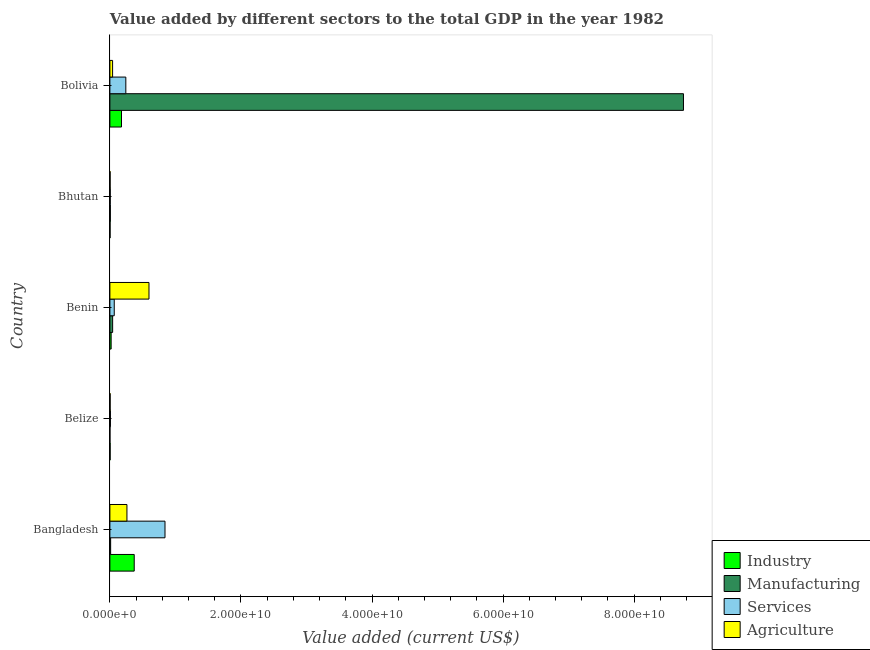How many different coloured bars are there?
Offer a very short reply. 4. Are the number of bars per tick equal to the number of legend labels?
Give a very brief answer. Yes. How many bars are there on the 4th tick from the top?
Offer a terse response. 4. How many bars are there on the 5th tick from the bottom?
Provide a succinct answer. 4. What is the label of the 5th group of bars from the top?
Give a very brief answer. Bangladesh. What is the value added by manufacturing sector in Benin?
Offer a terse response. 4.20e+08. Across all countries, what is the maximum value added by industrial sector?
Make the answer very short. 3.71e+09. Across all countries, what is the minimum value added by services sector?
Give a very brief answer. 5.63e+07. In which country was the value added by industrial sector minimum?
Your answer should be very brief. Bhutan. What is the total value added by industrial sector in the graph?
Make the answer very short. 5.74e+09. What is the difference between the value added by services sector in Benin and that in Bhutan?
Offer a very short reply. 6.08e+08. What is the difference between the value added by manufacturing sector in Bangladesh and the value added by agricultural sector in Belize?
Provide a short and direct response. 7.68e+07. What is the average value added by industrial sector per country?
Ensure brevity in your answer.  1.15e+09. What is the difference between the value added by industrial sector and value added by agricultural sector in Bangladesh?
Offer a very short reply. 1.11e+09. What is the ratio of the value added by services sector in Bhutan to that in Bolivia?
Offer a very short reply. 0.02. Is the value added by manufacturing sector in Bangladesh less than that in Belize?
Give a very brief answer. No. Is the difference between the value added by services sector in Belize and Bhutan greater than the difference between the value added by agricultural sector in Belize and Bhutan?
Your response must be concise. Yes. What is the difference between the highest and the second highest value added by agricultural sector?
Your answer should be compact. 3.36e+09. What is the difference between the highest and the lowest value added by agricultural sector?
Your response must be concise. 5.93e+09. In how many countries, is the value added by manufacturing sector greater than the average value added by manufacturing sector taken over all countries?
Keep it short and to the point. 1. Is the sum of the value added by services sector in Belize and Bhutan greater than the maximum value added by agricultural sector across all countries?
Your response must be concise. No. Is it the case that in every country, the sum of the value added by manufacturing sector and value added by agricultural sector is greater than the sum of value added by industrial sector and value added by services sector?
Keep it short and to the point. No. What does the 2nd bar from the top in Bangladesh represents?
Provide a succinct answer. Services. What does the 3rd bar from the bottom in Bangladesh represents?
Provide a short and direct response. Services. Is it the case that in every country, the sum of the value added by industrial sector and value added by manufacturing sector is greater than the value added by services sector?
Make the answer very short. No. How many bars are there?
Your answer should be compact. 20. What is the difference between two consecutive major ticks on the X-axis?
Your response must be concise. 2.00e+1. Are the values on the major ticks of X-axis written in scientific E-notation?
Ensure brevity in your answer.  Yes. Does the graph contain grids?
Provide a short and direct response. No. How many legend labels are there?
Your response must be concise. 4. How are the legend labels stacked?
Provide a short and direct response. Vertical. What is the title of the graph?
Ensure brevity in your answer.  Value added by different sectors to the total GDP in the year 1982. Does "UNPBF" appear as one of the legend labels in the graph?
Ensure brevity in your answer.  No. What is the label or title of the X-axis?
Provide a succinct answer. Value added (current US$). What is the Value added (current US$) in Industry in Bangladesh?
Offer a terse response. 3.71e+09. What is the Value added (current US$) in Manufacturing in Bangladesh?
Offer a very short reply. 1.15e+08. What is the Value added (current US$) in Services in Bangladesh?
Offer a very short reply. 8.41e+09. What is the Value added (current US$) of Agriculture in Bangladesh?
Your answer should be compact. 2.60e+09. What is the Value added (current US$) in Industry in Belize?
Offer a very short reply. 3.82e+07. What is the Value added (current US$) of Manufacturing in Belize?
Offer a terse response. 8.23e+06. What is the Value added (current US$) in Services in Belize?
Make the answer very short. 8.36e+07. What is the Value added (current US$) in Agriculture in Belize?
Your response must be concise. 3.86e+07. What is the Value added (current US$) of Industry in Benin?
Provide a succinct answer. 1.92e+08. What is the Value added (current US$) in Manufacturing in Benin?
Keep it short and to the point. 4.20e+08. What is the Value added (current US$) of Services in Benin?
Offer a very short reply. 6.64e+08. What is the Value added (current US$) in Agriculture in Benin?
Your answer should be compact. 5.96e+09. What is the Value added (current US$) of Industry in Bhutan?
Offer a terse response. 2.83e+07. What is the Value added (current US$) of Manufacturing in Bhutan?
Keep it short and to the point. 6.89e+07. What is the Value added (current US$) of Services in Bhutan?
Your answer should be very brief. 5.63e+07. What is the Value added (current US$) of Agriculture in Bhutan?
Provide a succinct answer. 3.54e+07. What is the Value added (current US$) of Industry in Bolivia?
Give a very brief answer. 1.77e+09. What is the Value added (current US$) in Manufacturing in Bolivia?
Provide a short and direct response. 8.75e+1. What is the Value added (current US$) in Services in Bolivia?
Ensure brevity in your answer.  2.43e+09. What is the Value added (current US$) in Agriculture in Bolivia?
Make the answer very short. 4.12e+08. Across all countries, what is the maximum Value added (current US$) in Industry?
Give a very brief answer. 3.71e+09. Across all countries, what is the maximum Value added (current US$) in Manufacturing?
Give a very brief answer. 8.75e+1. Across all countries, what is the maximum Value added (current US$) of Services?
Make the answer very short. 8.41e+09. Across all countries, what is the maximum Value added (current US$) in Agriculture?
Provide a succinct answer. 5.96e+09. Across all countries, what is the minimum Value added (current US$) of Industry?
Give a very brief answer. 2.83e+07. Across all countries, what is the minimum Value added (current US$) of Manufacturing?
Make the answer very short. 8.23e+06. Across all countries, what is the minimum Value added (current US$) of Services?
Your answer should be very brief. 5.63e+07. Across all countries, what is the minimum Value added (current US$) of Agriculture?
Provide a short and direct response. 3.54e+07. What is the total Value added (current US$) in Industry in the graph?
Ensure brevity in your answer.  5.74e+09. What is the total Value added (current US$) of Manufacturing in the graph?
Provide a short and direct response. 8.81e+1. What is the total Value added (current US$) in Services in the graph?
Your answer should be very brief. 1.16e+1. What is the total Value added (current US$) of Agriculture in the graph?
Your response must be concise. 9.05e+09. What is the difference between the Value added (current US$) of Industry in Bangladesh and that in Belize?
Ensure brevity in your answer.  3.67e+09. What is the difference between the Value added (current US$) of Manufacturing in Bangladesh and that in Belize?
Offer a terse response. 1.07e+08. What is the difference between the Value added (current US$) of Services in Bangladesh and that in Belize?
Ensure brevity in your answer.  8.32e+09. What is the difference between the Value added (current US$) in Agriculture in Bangladesh and that in Belize?
Provide a succinct answer. 2.56e+09. What is the difference between the Value added (current US$) in Industry in Bangladesh and that in Benin?
Provide a short and direct response. 3.52e+09. What is the difference between the Value added (current US$) of Manufacturing in Bangladesh and that in Benin?
Provide a short and direct response. -3.04e+08. What is the difference between the Value added (current US$) of Services in Bangladesh and that in Benin?
Give a very brief answer. 7.74e+09. What is the difference between the Value added (current US$) in Agriculture in Bangladesh and that in Benin?
Give a very brief answer. -3.36e+09. What is the difference between the Value added (current US$) of Industry in Bangladesh and that in Bhutan?
Your response must be concise. 3.68e+09. What is the difference between the Value added (current US$) in Manufacturing in Bangladesh and that in Bhutan?
Your answer should be compact. 4.64e+07. What is the difference between the Value added (current US$) in Services in Bangladesh and that in Bhutan?
Ensure brevity in your answer.  8.35e+09. What is the difference between the Value added (current US$) in Agriculture in Bangladesh and that in Bhutan?
Give a very brief answer. 2.56e+09. What is the difference between the Value added (current US$) in Industry in Bangladesh and that in Bolivia?
Your response must be concise. 1.94e+09. What is the difference between the Value added (current US$) of Manufacturing in Bangladesh and that in Bolivia?
Make the answer very short. -8.74e+1. What is the difference between the Value added (current US$) of Services in Bangladesh and that in Bolivia?
Your response must be concise. 5.98e+09. What is the difference between the Value added (current US$) of Agriculture in Bangladesh and that in Bolivia?
Your response must be concise. 2.19e+09. What is the difference between the Value added (current US$) of Industry in Belize and that in Benin?
Provide a short and direct response. -1.54e+08. What is the difference between the Value added (current US$) of Manufacturing in Belize and that in Benin?
Your answer should be compact. -4.12e+08. What is the difference between the Value added (current US$) of Services in Belize and that in Benin?
Keep it short and to the point. -5.80e+08. What is the difference between the Value added (current US$) of Agriculture in Belize and that in Benin?
Provide a succinct answer. -5.93e+09. What is the difference between the Value added (current US$) in Industry in Belize and that in Bhutan?
Keep it short and to the point. 9.86e+06. What is the difference between the Value added (current US$) of Manufacturing in Belize and that in Bhutan?
Give a very brief answer. -6.07e+07. What is the difference between the Value added (current US$) of Services in Belize and that in Bhutan?
Make the answer very short. 2.73e+07. What is the difference between the Value added (current US$) in Agriculture in Belize and that in Bhutan?
Your answer should be very brief. 3.16e+06. What is the difference between the Value added (current US$) in Industry in Belize and that in Bolivia?
Your answer should be very brief. -1.73e+09. What is the difference between the Value added (current US$) in Manufacturing in Belize and that in Bolivia?
Provide a succinct answer. -8.75e+1. What is the difference between the Value added (current US$) in Services in Belize and that in Bolivia?
Provide a short and direct response. -2.35e+09. What is the difference between the Value added (current US$) of Agriculture in Belize and that in Bolivia?
Make the answer very short. -3.73e+08. What is the difference between the Value added (current US$) of Industry in Benin and that in Bhutan?
Offer a very short reply. 1.63e+08. What is the difference between the Value added (current US$) in Manufacturing in Benin and that in Bhutan?
Keep it short and to the point. 3.51e+08. What is the difference between the Value added (current US$) in Services in Benin and that in Bhutan?
Offer a very short reply. 6.08e+08. What is the difference between the Value added (current US$) of Agriculture in Benin and that in Bhutan?
Make the answer very short. 5.93e+09. What is the difference between the Value added (current US$) in Industry in Benin and that in Bolivia?
Ensure brevity in your answer.  -1.58e+09. What is the difference between the Value added (current US$) of Manufacturing in Benin and that in Bolivia?
Offer a very short reply. -8.71e+1. What is the difference between the Value added (current US$) of Services in Benin and that in Bolivia?
Provide a short and direct response. -1.77e+09. What is the difference between the Value added (current US$) in Agriculture in Benin and that in Bolivia?
Provide a succinct answer. 5.55e+09. What is the difference between the Value added (current US$) of Industry in Bhutan and that in Bolivia?
Keep it short and to the point. -1.74e+09. What is the difference between the Value added (current US$) of Manufacturing in Bhutan and that in Bolivia?
Provide a succinct answer. -8.75e+1. What is the difference between the Value added (current US$) in Services in Bhutan and that in Bolivia?
Offer a very short reply. -2.38e+09. What is the difference between the Value added (current US$) of Agriculture in Bhutan and that in Bolivia?
Give a very brief answer. -3.77e+08. What is the difference between the Value added (current US$) of Industry in Bangladesh and the Value added (current US$) of Manufacturing in Belize?
Make the answer very short. 3.70e+09. What is the difference between the Value added (current US$) in Industry in Bangladesh and the Value added (current US$) in Services in Belize?
Keep it short and to the point. 3.63e+09. What is the difference between the Value added (current US$) in Industry in Bangladesh and the Value added (current US$) in Agriculture in Belize?
Offer a very short reply. 3.67e+09. What is the difference between the Value added (current US$) in Manufacturing in Bangladesh and the Value added (current US$) in Services in Belize?
Your answer should be compact. 3.17e+07. What is the difference between the Value added (current US$) of Manufacturing in Bangladesh and the Value added (current US$) of Agriculture in Belize?
Ensure brevity in your answer.  7.68e+07. What is the difference between the Value added (current US$) in Services in Bangladesh and the Value added (current US$) in Agriculture in Belize?
Your answer should be compact. 8.37e+09. What is the difference between the Value added (current US$) in Industry in Bangladesh and the Value added (current US$) in Manufacturing in Benin?
Ensure brevity in your answer.  3.29e+09. What is the difference between the Value added (current US$) of Industry in Bangladesh and the Value added (current US$) of Services in Benin?
Your answer should be very brief. 3.05e+09. What is the difference between the Value added (current US$) in Industry in Bangladesh and the Value added (current US$) in Agriculture in Benin?
Provide a short and direct response. -2.25e+09. What is the difference between the Value added (current US$) in Manufacturing in Bangladesh and the Value added (current US$) in Services in Benin?
Give a very brief answer. -5.49e+08. What is the difference between the Value added (current US$) of Manufacturing in Bangladesh and the Value added (current US$) of Agriculture in Benin?
Give a very brief answer. -5.85e+09. What is the difference between the Value added (current US$) of Services in Bangladesh and the Value added (current US$) of Agriculture in Benin?
Make the answer very short. 2.44e+09. What is the difference between the Value added (current US$) in Industry in Bangladesh and the Value added (current US$) in Manufacturing in Bhutan?
Your answer should be very brief. 3.64e+09. What is the difference between the Value added (current US$) in Industry in Bangladesh and the Value added (current US$) in Services in Bhutan?
Give a very brief answer. 3.66e+09. What is the difference between the Value added (current US$) in Industry in Bangladesh and the Value added (current US$) in Agriculture in Bhutan?
Make the answer very short. 3.68e+09. What is the difference between the Value added (current US$) of Manufacturing in Bangladesh and the Value added (current US$) of Services in Bhutan?
Your answer should be very brief. 5.90e+07. What is the difference between the Value added (current US$) of Manufacturing in Bangladesh and the Value added (current US$) of Agriculture in Bhutan?
Ensure brevity in your answer.  7.99e+07. What is the difference between the Value added (current US$) of Services in Bangladesh and the Value added (current US$) of Agriculture in Bhutan?
Your answer should be compact. 8.37e+09. What is the difference between the Value added (current US$) of Industry in Bangladesh and the Value added (current US$) of Manufacturing in Bolivia?
Provide a succinct answer. -8.38e+1. What is the difference between the Value added (current US$) in Industry in Bangladesh and the Value added (current US$) in Services in Bolivia?
Give a very brief answer. 1.28e+09. What is the difference between the Value added (current US$) in Industry in Bangladesh and the Value added (current US$) in Agriculture in Bolivia?
Give a very brief answer. 3.30e+09. What is the difference between the Value added (current US$) of Manufacturing in Bangladesh and the Value added (current US$) of Services in Bolivia?
Your answer should be compact. -2.32e+09. What is the difference between the Value added (current US$) in Manufacturing in Bangladesh and the Value added (current US$) in Agriculture in Bolivia?
Your answer should be compact. -2.97e+08. What is the difference between the Value added (current US$) in Services in Bangladesh and the Value added (current US$) in Agriculture in Bolivia?
Keep it short and to the point. 8.00e+09. What is the difference between the Value added (current US$) of Industry in Belize and the Value added (current US$) of Manufacturing in Benin?
Offer a terse response. -3.82e+08. What is the difference between the Value added (current US$) in Industry in Belize and the Value added (current US$) in Services in Benin?
Offer a very short reply. -6.26e+08. What is the difference between the Value added (current US$) of Industry in Belize and the Value added (current US$) of Agriculture in Benin?
Give a very brief answer. -5.93e+09. What is the difference between the Value added (current US$) of Manufacturing in Belize and the Value added (current US$) of Services in Benin?
Offer a very short reply. -6.56e+08. What is the difference between the Value added (current US$) of Manufacturing in Belize and the Value added (current US$) of Agriculture in Benin?
Your answer should be very brief. -5.96e+09. What is the difference between the Value added (current US$) of Services in Belize and the Value added (current US$) of Agriculture in Benin?
Your response must be concise. -5.88e+09. What is the difference between the Value added (current US$) of Industry in Belize and the Value added (current US$) of Manufacturing in Bhutan?
Your response must be concise. -3.07e+07. What is the difference between the Value added (current US$) in Industry in Belize and the Value added (current US$) in Services in Bhutan?
Your response must be concise. -1.81e+07. What is the difference between the Value added (current US$) of Industry in Belize and the Value added (current US$) of Agriculture in Bhutan?
Give a very brief answer. 2.80e+06. What is the difference between the Value added (current US$) of Manufacturing in Belize and the Value added (current US$) of Services in Bhutan?
Provide a succinct answer. -4.81e+07. What is the difference between the Value added (current US$) in Manufacturing in Belize and the Value added (current US$) in Agriculture in Bhutan?
Offer a very short reply. -2.72e+07. What is the difference between the Value added (current US$) of Services in Belize and the Value added (current US$) of Agriculture in Bhutan?
Your answer should be very brief. 4.82e+07. What is the difference between the Value added (current US$) in Industry in Belize and the Value added (current US$) in Manufacturing in Bolivia?
Offer a terse response. -8.75e+1. What is the difference between the Value added (current US$) in Industry in Belize and the Value added (current US$) in Services in Bolivia?
Provide a short and direct response. -2.39e+09. What is the difference between the Value added (current US$) of Industry in Belize and the Value added (current US$) of Agriculture in Bolivia?
Provide a succinct answer. -3.74e+08. What is the difference between the Value added (current US$) in Manufacturing in Belize and the Value added (current US$) in Services in Bolivia?
Provide a short and direct response. -2.42e+09. What is the difference between the Value added (current US$) of Manufacturing in Belize and the Value added (current US$) of Agriculture in Bolivia?
Offer a very short reply. -4.04e+08. What is the difference between the Value added (current US$) in Services in Belize and the Value added (current US$) in Agriculture in Bolivia?
Ensure brevity in your answer.  -3.28e+08. What is the difference between the Value added (current US$) of Industry in Benin and the Value added (current US$) of Manufacturing in Bhutan?
Keep it short and to the point. 1.23e+08. What is the difference between the Value added (current US$) of Industry in Benin and the Value added (current US$) of Services in Bhutan?
Keep it short and to the point. 1.35e+08. What is the difference between the Value added (current US$) in Industry in Benin and the Value added (current US$) in Agriculture in Bhutan?
Keep it short and to the point. 1.56e+08. What is the difference between the Value added (current US$) of Manufacturing in Benin and the Value added (current US$) of Services in Bhutan?
Offer a terse response. 3.63e+08. What is the difference between the Value added (current US$) of Manufacturing in Benin and the Value added (current US$) of Agriculture in Bhutan?
Your answer should be very brief. 3.84e+08. What is the difference between the Value added (current US$) in Services in Benin and the Value added (current US$) in Agriculture in Bhutan?
Make the answer very short. 6.29e+08. What is the difference between the Value added (current US$) of Industry in Benin and the Value added (current US$) of Manufacturing in Bolivia?
Keep it short and to the point. -8.73e+1. What is the difference between the Value added (current US$) in Industry in Benin and the Value added (current US$) in Services in Bolivia?
Make the answer very short. -2.24e+09. What is the difference between the Value added (current US$) of Industry in Benin and the Value added (current US$) of Agriculture in Bolivia?
Your response must be concise. -2.20e+08. What is the difference between the Value added (current US$) in Manufacturing in Benin and the Value added (current US$) in Services in Bolivia?
Your response must be concise. -2.01e+09. What is the difference between the Value added (current US$) of Manufacturing in Benin and the Value added (current US$) of Agriculture in Bolivia?
Make the answer very short. 7.73e+06. What is the difference between the Value added (current US$) in Services in Benin and the Value added (current US$) in Agriculture in Bolivia?
Your response must be concise. 2.52e+08. What is the difference between the Value added (current US$) in Industry in Bhutan and the Value added (current US$) in Manufacturing in Bolivia?
Your answer should be very brief. -8.75e+1. What is the difference between the Value added (current US$) of Industry in Bhutan and the Value added (current US$) of Services in Bolivia?
Provide a succinct answer. -2.40e+09. What is the difference between the Value added (current US$) of Industry in Bhutan and the Value added (current US$) of Agriculture in Bolivia?
Provide a succinct answer. -3.84e+08. What is the difference between the Value added (current US$) in Manufacturing in Bhutan and the Value added (current US$) in Services in Bolivia?
Your response must be concise. -2.36e+09. What is the difference between the Value added (current US$) of Manufacturing in Bhutan and the Value added (current US$) of Agriculture in Bolivia?
Your response must be concise. -3.43e+08. What is the difference between the Value added (current US$) of Services in Bhutan and the Value added (current US$) of Agriculture in Bolivia?
Make the answer very short. -3.56e+08. What is the average Value added (current US$) in Industry per country?
Your answer should be compact. 1.15e+09. What is the average Value added (current US$) in Manufacturing per country?
Provide a succinct answer. 1.76e+1. What is the average Value added (current US$) in Services per country?
Make the answer very short. 2.33e+09. What is the average Value added (current US$) in Agriculture per country?
Your answer should be very brief. 1.81e+09. What is the difference between the Value added (current US$) of Industry and Value added (current US$) of Manufacturing in Bangladesh?
Offer a terse response. 3.60e+09. What is the difference between the Value added (current US$) in Industry and Value added (current US$) in Services in Bangladesh?
Offer a terse response. -4.70e+09. What is the difference between the Value added (current US$) in Industry and Value added (current US$) in Agriculture in Bangladesh?
Keep it short and to the point. 1.11e+09. What is the difference between the Value added (current US$) of Manufacturing and Value added (current US$) of Services in Bangladesh?
Your response must be concise. -8.29e+09. What is the difference between the Value added (current US$) in Manufacturing and Value added (current US$) in Agriculture in Bangladesh?
Your answer should be very brief. -2.48e+09. What is the difference between the Value added (current US$) in Services and Value added (current US$) in Agriculture in Bangladesh?
Offer a very short reply. 5.81e+09. What is the difference between the Value added (current US$) of Industry and Value added (current US$) of Manufacturing in Belize?
Give a very brief answer. 3.00e+07. What is the difference between the Value added (current US$) in Industry and Value added (current US$) in Services in Belize?
Your answer should be compact. -4.54e+07. What is the difference between the Value added (current US$) of Industry and Value added (current US$) of Agriculture in Belize?
Ensure brevity in your answer.  -3.64e+05. What is the difference between the Value added (current US$) in Manufacturing and Value added (current US$) in Services in Belize?
Give a very brief answer. -7.54e+07. What is the difference between the Value added (current US$) of Manufacturing and Value added (current US$) of Agriculture in Belize?
Give a very brief answer. -3.03e+07. What is the difference between the Value added (current US$) in Services and Value added (current US$) in Agriculture in Belize?
Give a very brief answer. 4.51e+07. What is the difference between the Value added (current US$) in Industry and Value added (current US$) in Manufacturing in Benin?
Provide a succinct answer. -2.28e+08. What is the difference between the Value added (current US$) of Industry and Value added (current US$) of Services in Benin?
Make the answer very short. -4.72e+08. What is the difference between the Value added (current US$) in Industry and Value added (current US$) in Agriculture in Benin?
Make the answer very short. -5.77e+09. What is the difference between the Value added (current US$) of Manufacturing and Value added (current US$) of Services in Benin?
Keep it short and to the point. -2.44e+08. What is the difference between the Value added (current US$) in Manufacturing and Value added (current US$) in Agriculture in Benin?
Offer a terse response. -5.55e+09. What is the difference between the Value added (current US$) of Services and Value added (current US$) of Agriculture in Benin?
Provide a succinct answer. -5.30e+09. What is the difference between the Value added (current US$) in Industry and Value added (current US$) in Manufacturing in Bhutan?
Your response must be concise. -4.06e+07. What is the difference between the Value added (current US$) in Industry and Value added (current US$) in Services in Bhutan?
Offer a terse response. -2.80e+07. What is the difference between the Value added (current US$) in Industry and Value added (current US$) in Agriculture in Bhutan?
Provide a succinct answer. -7.06e+06. What is the difference between the Value added (current US$) in Manufacturing and Value added (current US$) in Services in Bhutan?
Your answer should be very brief. 1.26e+07. What is the difference between the Value added (current US$) of Manufacturing and Value added (current US$) of Agriculture in Bhutan?
Your answer should be compact. 3.35e+07. What is the difference between the Value added (current US$) of Services and Value added (current US$) of Agriculture in Bhutan?
Make the answer very short. 2.09e+07. What is the difference between the Value added (current US$) in Industry and Value added (current US$) in Manufacturing in Bolivia?
Offer a terse response. -8.58e+1. What is the difference between the Value added (current US$) of Industry and Value added (current US$) of Services in Bolivia?
Ensure brevity in your answer.  -6.60e+08. What is the difference between the Value added (current US$) of Industry and Value added (current US$) of Agriculture in Bolivia?
Your answer should be compact. 1.36e+09. What is the difference between the Value added (current US$) in Manufacturing and Value added (current US$) in Services in Bolivia?
Give a very brief answer. 8.51e+1. What is the difference between the Value added (current US$) in Manufacturing and Value added (current US$) in Agriculture in Bolivia?
Your response must be concise. 8.71e+1. What is the difference between the Value added (current US$) of Services and Value added (current US$) of Agriculture in Bolivia?
Ensure brevity in your answer.  2.02e+09. What is the ratio of the Value added (current US$) in Industry in Bangladesh to that in Belize?
Make the answer very short. 97.2. What is the ratio of the Value added (current US$) of Manufacturing in Bangladesh to that in Belize?
Keep it short and to the point. 14.02. What is the ratio of the Value added (current US$) in Services in Bangladesh to that in Belize?
Provide a succinct answer. 100.52. What is the ratio of the Value added (current US$) of Agriculture in Bangladesh to that in Belize?
Make the answer very short. 67.42. What is the ratio of the Value added (current US$) of Industry in Bangladesh to that in Benin?
Your answer should be very brief. 19.37. What is the ratio of the Value added (current US$) of Manufacturing in Bangladesh to that in Benin?
Provide a short and direct response. 0.27. What is the ratio of the Value added (current US$) in Services in Bangladesh to that in Benin?
Your response must be concise. 12.66. What is the ratio of the Value added (current US$) of Agriculture in Bangladesh to that in Benin?
Provide a succinct answer. 0.44. What is the ratio of the Value added (current US$) of Industry in Bangladesh to that in Bhutan?
Your answer should be compact. 131. What is the ratio of the Value added (current US$) of Manufacturing in Bangladesh to that in Bhutan?
Provide a succinct answer. 1.67. What is the ratio of the Value added (current US$) of Services in Bangladesh to that in Bhutan?
Ensure brevity in your answer.  149.27. What is the ratio of the Value added (current US$) in Agriculture in Bangladesh to that in Bhutan?
Give a very brief answer. 73.44. What is the ratio of the Value added (current US$) in Industry in Bangladesh to that in Bolivia?
Make the answer very short. 2.09. What is the ratio of the Value added (current US$) of Manufacturing in Bangladesh to that in Bolivia?
Ensure brevity in your answer.  0. What is the ratio of the Value added (current US$) in Services in Bangladesh to that in Bolivia?
Your response must be concise. 3.46. What is the ratio of the Value added (current US$) of Agriculture in Bangladesh to that in Bolivia?
Keep it short and to the point. 6.31. What is the ratio of the Value added (current US$) in Industry in Belize to that in Benin?
Give a very brief answer. 0.2. What is the ratio of the Value added (current US$) of Manufacturing in Belize to that in Benin?
Ensure brevity in your answer.  0.02. What is the ratio of the Value added (current US$) in Services in Belize to that in Benin?
Ensure brevity in your answer.  0.13. What is the ratio of the Value added (current US$) in Agriculture in Belize to that in Benin?
Your response must be concise. 0.01. What is the ratio of the Value added (current US$) in Industry in Belize to that in Bhutan?
Your answer should be very brief. 1.35. What is the ratio of the Value added (current US$) in Manufacturing in Belize to that in Bhutan?
Make the answer very short. 0.12. What is the ratio of the Value added (current US$) of Services in Belize to that in Bhutan?
Provide a short and direct response. 1.49. What is the ratio of the Value added (current US$) of Agriculture in Belize to that in Bhutan?
Offer a very short reply. 1.09. What is the ratio of the Value added (current US$) in Industry in Belize to that in Bolivia?
Make the answer very short. 0.02. What is the ratio of the Value added (current US$) of Services in Belize to that in Bolivia?
Give a very brief answer. 0.03. What is the ratio of the Value added (current US$) in Agriculture in Belize to that in Bolivia?
Provide a short and direct response. 0.09. What is the ratio of the Value added (current US$) of Industry in Benin to that in Bhutan?
Your response must be concise. 6.76. What is the ratio of the Value added (current US$) of Manufacturing in Benin to that in Bhutan?
Provide a short and direct response. 6.09. What is the ratio of the Value added (current US$) in Services in Benin to that in Bhutan?
Provide a short and direct response. 11.79. What is the ratio of the Value added (current US$) in Agriculture in Benin to that in Bhutan?
Offer a terse response. 168.5. What is the ratio of the Value added (current US$) in Industry in Benin to that in Bolivia?
Offer a terse response. 0.11. What is the ratio of the Value added (current US$) in Manufacturing in Benin to that in Bolivia?
Offer a very short reply. 0. What is the ratio of the Value added (current US$) of Services in Benin to that in Bolivia?
Your response must be concise. 0.27. What is the ratio of the Value added (current US$) in Agriculture in Benin to that in Bolivia?
Provide a short and direct response. 14.48. What is the ratio of the Value added (current US$) in Industry in Bhutan to that in Bolivia?
Your answer should be compact. 0.02. What is the ratio of the Value added (current US$) of Manufacturing in Bhutan to that in Bolivia?
Provide a short and direct response. 0. What is the ratio of the Value added (current US$) of Services in Bhutan to that in Bolivia?
Make the answer very short. 0.02. What is the ratio of the Value added (current US$) of Agriculture in Bhutan to that in Bolivia?
Offer a very short reply. 0.09. What is the difference between the highest and the second highest Value added (current US$) of Industry?
Offer a terse response. 1.94e+09. What is the difference between the highest and the second highest Value added (current US$) in Manufacturing?
Offer a terse response. 8.71e+1. What is the difference between the highest and the second highest Value added (current US$) in Services?
Your answer should be compact. 5.98e+09. What is the difference between the highest and the second highest Value added (current US$) in Agriculture?
Provide a succinct answer. 3.36e+09. What is the difference between the highest and the lowest Value added (current US$) in Industry?
Offer a very short reply. 3.68e+09. What is the difference between the highest and the lowest Value added (current US$) in Manufacturing?
Make the answer very short. 8.75e+1. What is the difference between the highest and the lowest Value added (current US$) of Services?
Your answer should be compact. 8.35e+09. What is the difference between the highest and the lowest Value added (current US$) of Agriculture?
Make the answer very short. 5.93e+09. 